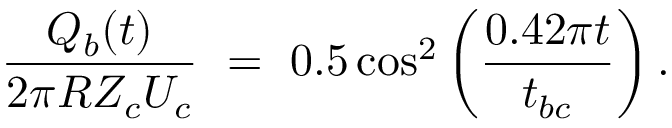Convert formula to latex. <formula><loc_0><loc_0><loc_500><loc_500>\frac { Q _ { b } ( t ) } { 2 \pi R Z _ { c } U _ { c } } = 0 . 5 \cos ^ { 2 } \left ( \frac { 0 . 4 2 \pi t } { t _ { b c } } \right ) .</formula> 